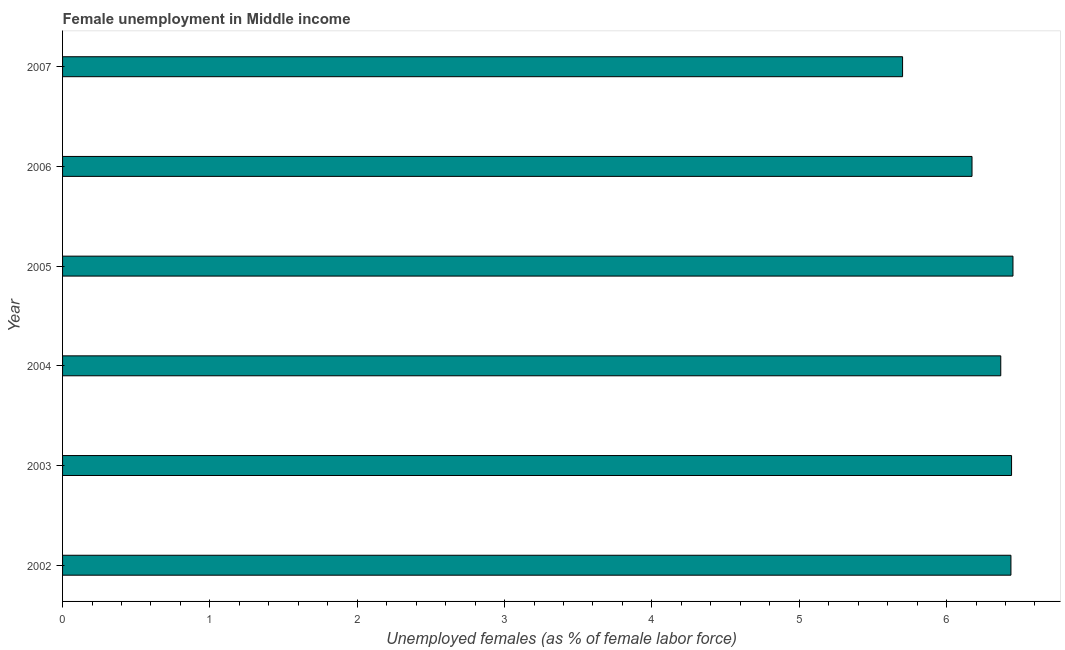Does the graph contain any zero values?
Your answer should be very brief. No. Does the graph contain grids?
Your answer should be very brief. No. What is the title of the graph?
Make the answer very short. Female unemployment in Middle income. What is the label or title of the X-axis?
Provide a short and direct response. Unemployed females (as % of female labor force). What is the label or title of the Y-axis?
Offer a very short reply. Year. What is the unemployed females population in 2003?
Keep it short and to the point. 6.44. Across all years, what is the maximum unemployed females population?
Keep it short and to the point. 6.45. Across all years, what is the minimum unemployed females population?
Keep it short and to the point. 5.7. In which year was the unemployed females population maximum?
Offer a terse response. 2005. In which year was the unemployed females population minimum?
Keep it short and to the point. 2007. What is the sum of the unemployed females population?
Keep it short and to the point. 37.57. What is the difference between the unemployed females population in 2004 and 2007?
Offer a very short reply. 0.67. What is the average unemployed females population per year?
Provide a short and direct response. 6.26. What is the median unemployed females population?
Offer a very short reply. 6.4. What is the ratio of the unemployed females population in 2003 to that in 2005?
Your response must be concise. 1. Is the unemployed females population in 2002 less than that in 2007?
Your answer should be very brief. No. Is the difference between the unemployed females population in 2003 and 2006 greater than the difference between any two years?
Your response must be concise. No. What is the difference between the highest and the second highest unemployed females population?
Your response must be concise. 0.01. What is the difference between the highest and the lowest unemployed females population?
Provide a short and direct response. 0.75. Are all the bars in the graph horizontal?
Make the answer very short. Yes. What is the difference between two consecutive major ticks on the X-axis?
Offer a very short reply. 1. What is the Unemployed females (as % of female labor force) of 2002?
Your response must be concise. 6.44. What is the Unemployed females (as % of female labor force) in 2003?
Give a very brief answer. 6.44. What is the Unemployed females (as % of female labor force) of 2004?
Provide a short and direct response. 6.37. What is the Unemployed females (as % of female labor force) of 2005?
Your response must be concise. 6.45. What is the Unemployed females (as % of female labor force) in 2006?
Offer a terse response. 6.17. What is the Unemployed females (as % of female labor force) of 2007?
Provide a short and direct response. 5.7. What is the difference between the Unemployed females (as % of female labor force) in 2002 and 2003?
Keep it short and to the point. -0. What is the difference between the Unemployed females (as % of female labor force) in 2002 and 2004?
Give a very brief answer. 0.07. What is the difference between the Unemployed females (as % of female labor force) in 2002 and 2005?
Make the answer very short. -0.01. What is the difference between the Unemployed females (as % of female labor force) in 2002 and 2006?
Your answer should be compact. 0.26. What is the difference between the Unemployed females (as % of female labor force) in 2002 and 2007?
Your answer should be very brief. 0.74. What is the difference between the Unemployed females (as % of female labor force) in 2003 and 2004?
Make the answer very short. 0.07. What is the difference between the Unemployed females (as % of female labor force) in 2003 and 2005?
Offer a terse response. -0.01. What is the difference between the Unemployed females (as % of female labor force) in 2003 and 2006?
Make the answer very short. 0.27. What is the difference between the Unemployed females (as % of female labor force) in 2003 and 2007?
Give a very brief answer. 0.74. What is the difference between the Unemployed females (as % of female labor force) in 2004 and 2005?
Provide a short and direct response. -0.08. What is the difference between the Unemployed females (as % of female labor force) in 2004 and 2006?
Make the answer very short. 0.2. What is the difference between the Unemployed females (as % of female labor force) in 2004 and 2007?
Give a very brief answer. 0.67. What is the difference between the Unemployed females (as % of female labor force) in 2005 and 2006?
Give a very brief answer. 0.28. What is the difference between the Unemployed females (as % of female labor force) in 2005 and 2007?
Make the answer very short. 0.75. What is the difference between the Unemployed females (as % of female labor force) in 2006 and 2007?
Give a very brief answer. 0.47. What is the ratio of the Unemployed females (as % of female labor force) in 2002 to that in 2004?
Provide a succinct answer. 1.01. What is the ratio of the Unemployed females (as % of female labor force) in 2002 to that in 2005?
Offer a terse response. 1. What is the ratio of the Unemployed females (as % of female labor force) in 2002 to that in 2006?
Offer a very short reply. 1.04. What is the ratio of the Unemployed females (as % of female labor force) in 2002 to that in 2007?
Keep it short and to the point. 1.13. What is the ratio of the Unemployed females (as % of female labor force) in 2003 to that in 2006?
Offer a terse response. 1.04. What is the ratio of the Unemployed females (as % of female labor force) in 2003 to that in 2007?
Provide a succinct answer. 1.13. What is the ratio of the Unemployed females (as % of female labor force) in 2004 to that in 2006?
Keep it short and to the point. 1.03. What is the ratio of the Unemployed females (as % of female labor force) in 2004 to that in 2007?
Your response must be concise. 1.12. What is the ratio of the Unemployed females (as % of female labor force) in 2005 to that in 2006?
Your answer should be very brief. 1.04. What is the ratio of the Unemployed females (as % of female labor force) in 2005 to that in 2007?
Keep it short and to the point. 1.13. What is the ratio of the Unemployed females (as % of female labor force) in 2006 to that in 2007?
Ensure brevity in your answer.  1.08. 